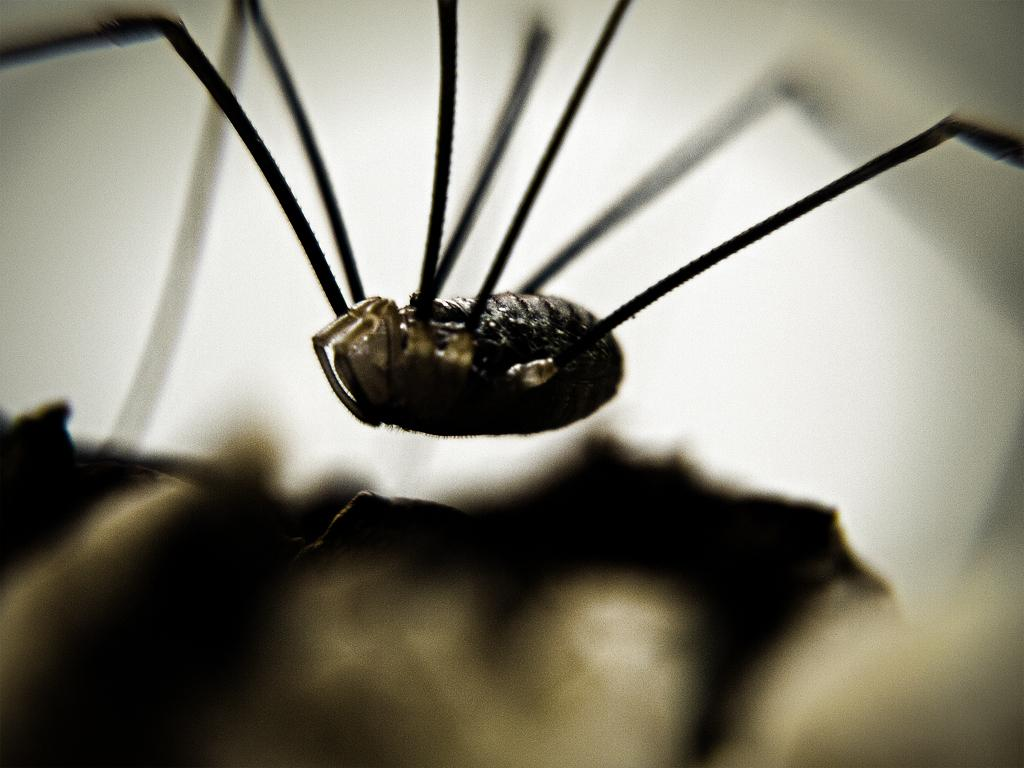What type of creature is present in the image? There is an insect in the image. Where is the insect located in the image? The insect is on a surface. What type of fire can be seen burning on the insect's root in the image? There is no fire or root present in the image; it features an insect on a surface. 